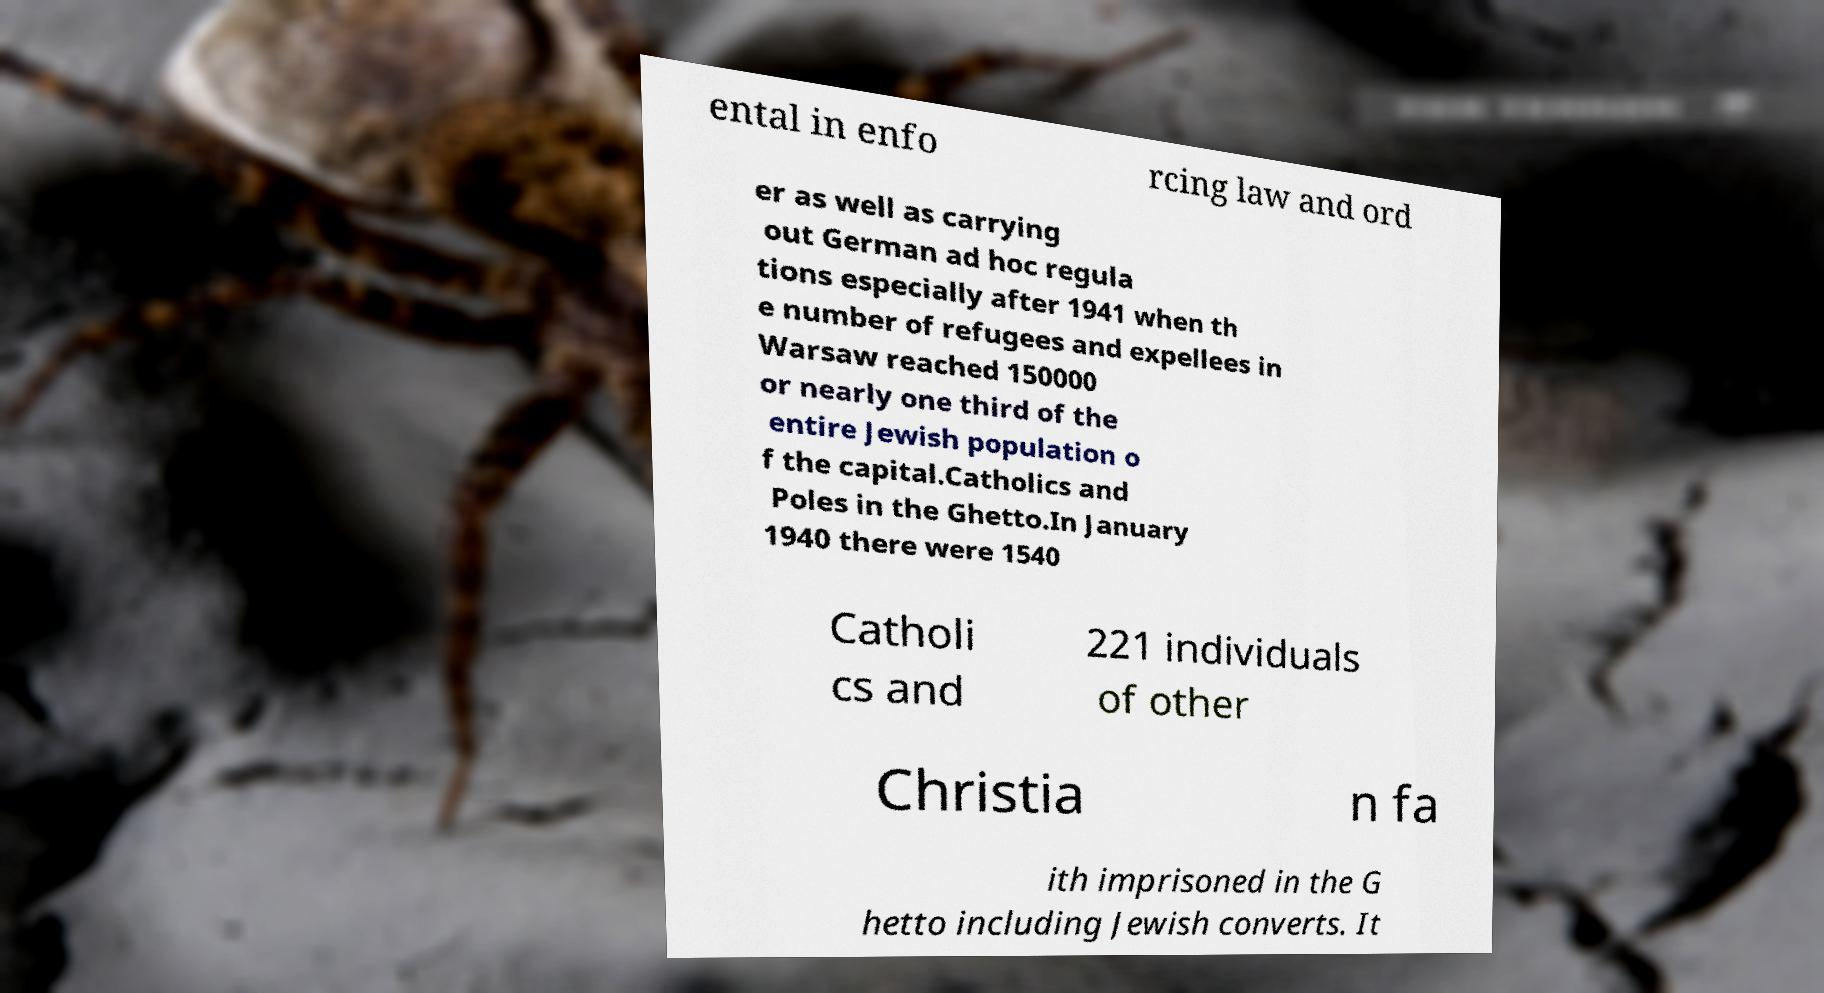There's text embedded in this image that I need extracted. Can you transcribe it verbatim? ental in enfo rcing law and ord er as well as carrying out German ad hoc regula tions especially after 1941 when th e number of refugees and expellees in Warsaw reached 150000 or nearly one third of the entire Jewish population o f the capital.Catholics and Poles in the Ghetto.In January 1940 there were 1540 Catholi cs and 221 individuals of other Christia n fa ith imprisoned in the G hetto including Jewish converts. It 